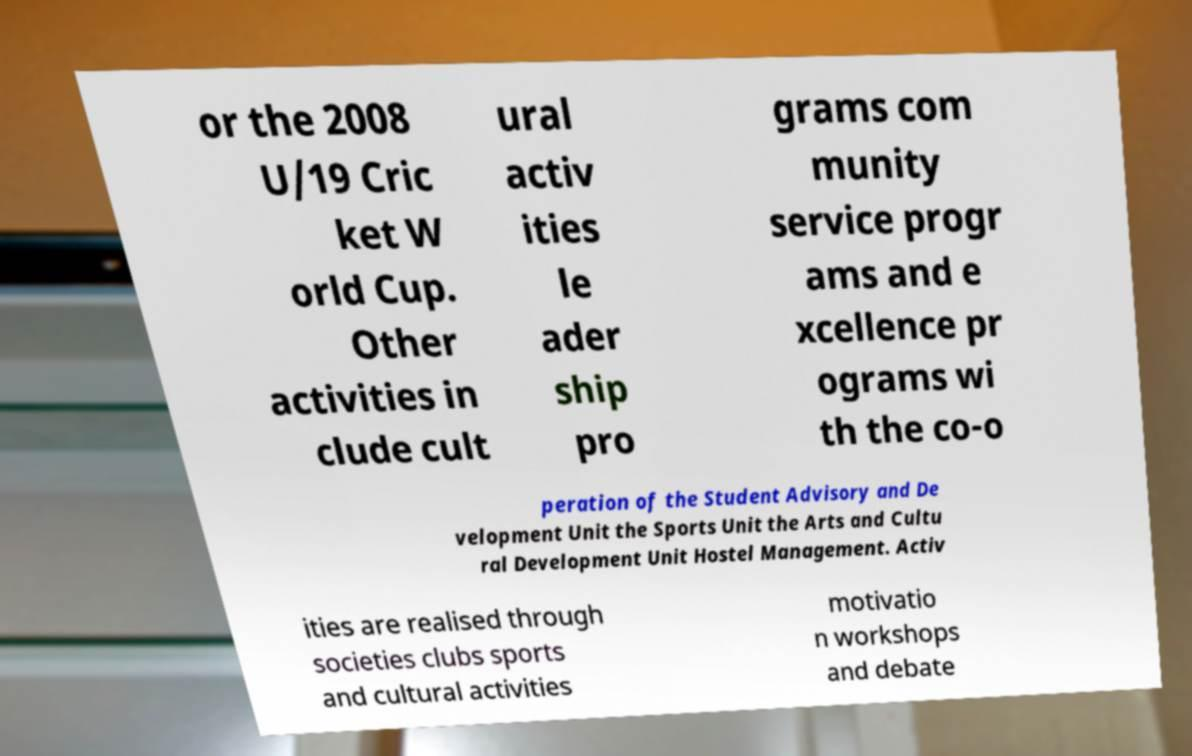Could you assist in decoding the text presented in this image and type it out clearly? or the 2008 U/19 Cric ket W orld Cup. Other activities in clude cult ural activ ities le ader ship pro grams com munity service progr ams and e xcellence pr ograms wi th the co-o peration of the Student Advisory and De velopment Unit the Sports Unit the Arts and Cultu ral Development Unit Hostel Management. Activ ities are realised through societies clubs sports and cultural activities motivatio n workshops and debate 